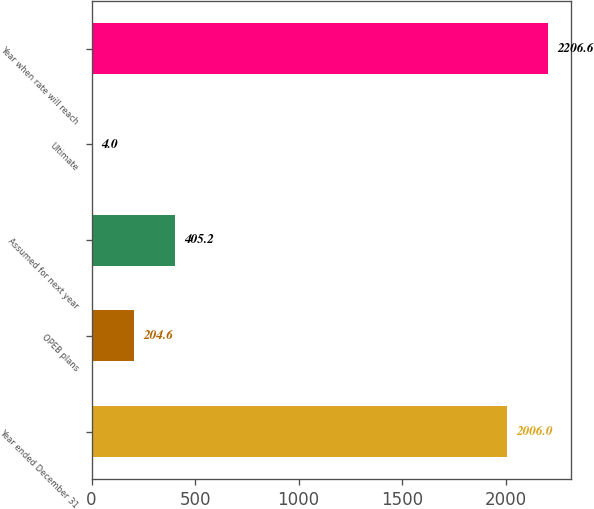Convert chart. <chart><loc_0><loc_0><loc_500><loc_500><bar_chart><fcel>Year ended December 31<fcel>OPEB plans<fcel>Assumed for next year<fcel>Ultimate<fcel>Year when rate will reach<nl><fcel>2006<fcel>204.6<fcel>405.2<fcel>4<fcel>2206.6<nl></chart> 